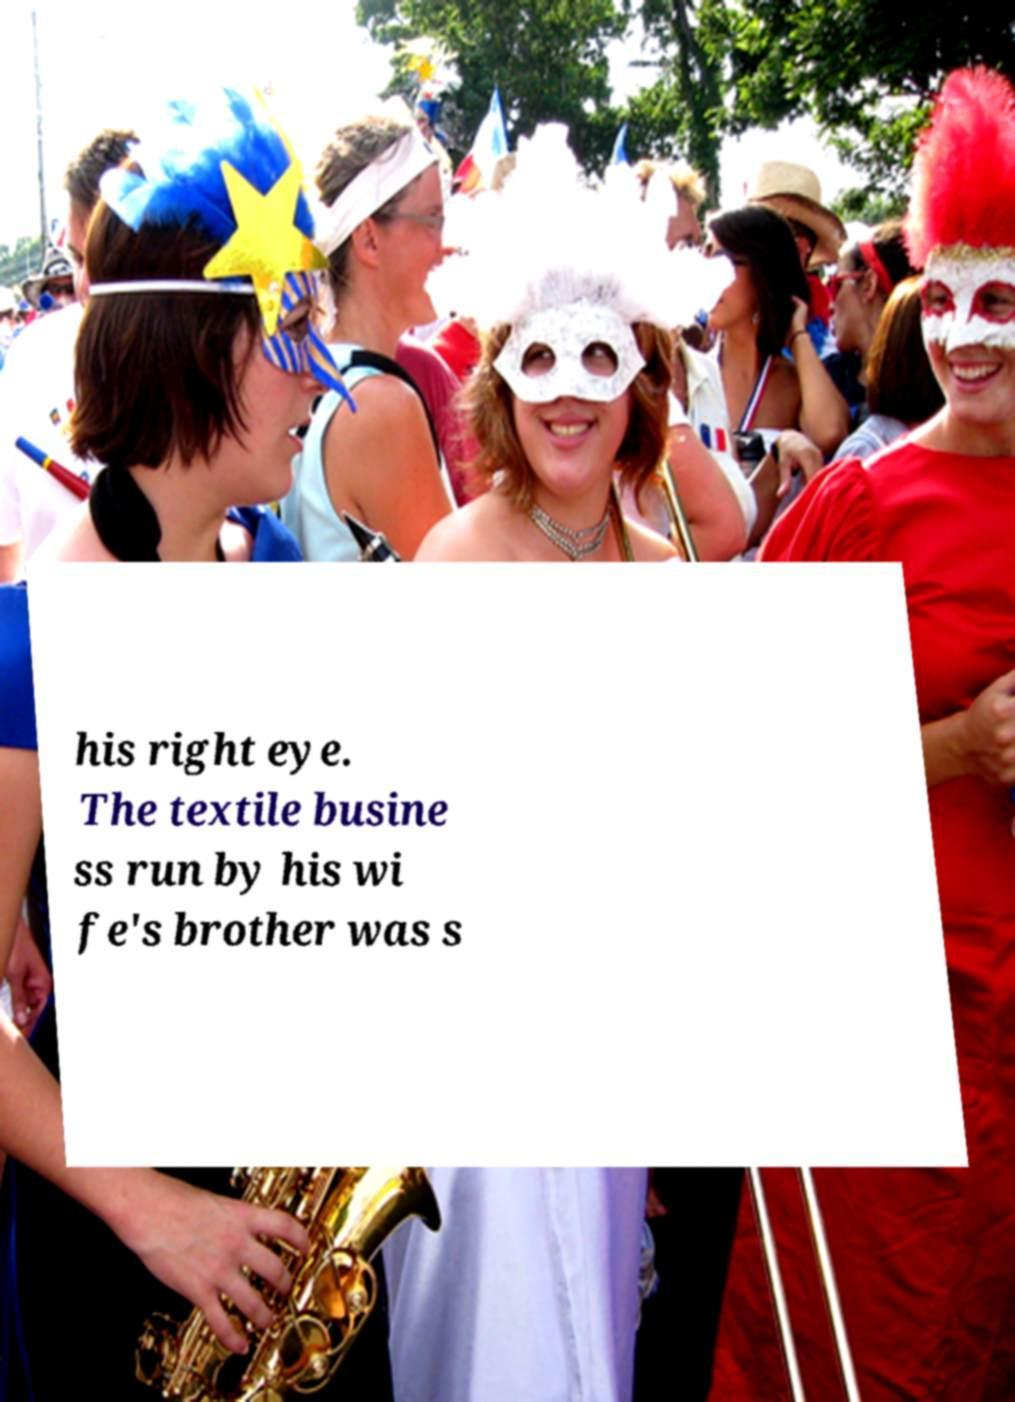Please read and relay the text visible in this image. What does it say? his right eye. The textile busine ss run by his wi fe's brother was s 